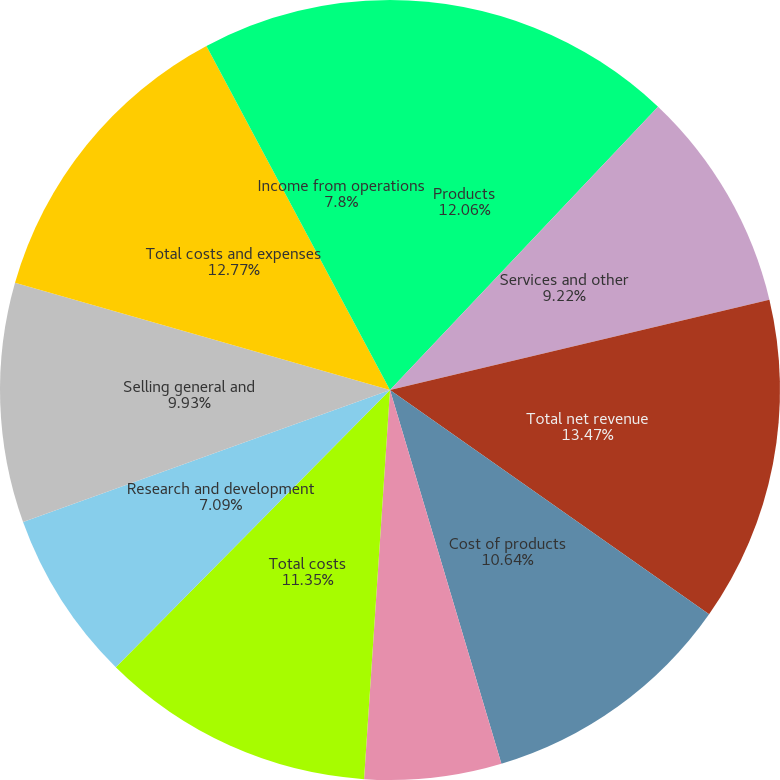<chart> <loc_0><loc_0><loc_500><loc_500><pie_chart><fcel>Products<fcel>Services and other<fcel>Total net revenue<fcel>Cost of products<fcel>Cost of services and other<fcel>Total costs<fcel>Research and development<fcel>Selling general and<fcel>Total costs and expenses<fcel>Income from operations<nl><fcel>12.06%<fcel>9.22%<fcel>13.47%<fcel>10.64%<fcel>5.67%<fcel>11.35%<fcel>7.09%<fcel>9.93%<fcel>12.77%<fcel>7.8%<nl></chart> 